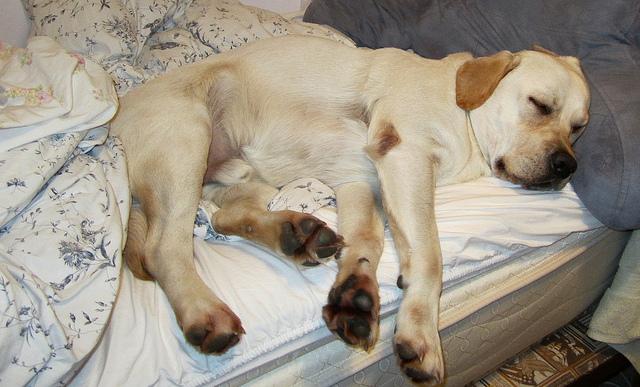Does this dog always stay indoors?
Be succinct. Yes. Is this dog comfortable?
Keep it brief. Yes. Is this dog awake?
Write a very short answer. No. 